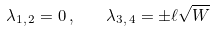<formula> <loc_0><loc_0><loc_500><loc_500>\lambda _ { 1 , \, 2 } = 0 \, , \quad \lambda _ { 3 , \, 4 } = \pm \ell \sqrt { W }</formula> 